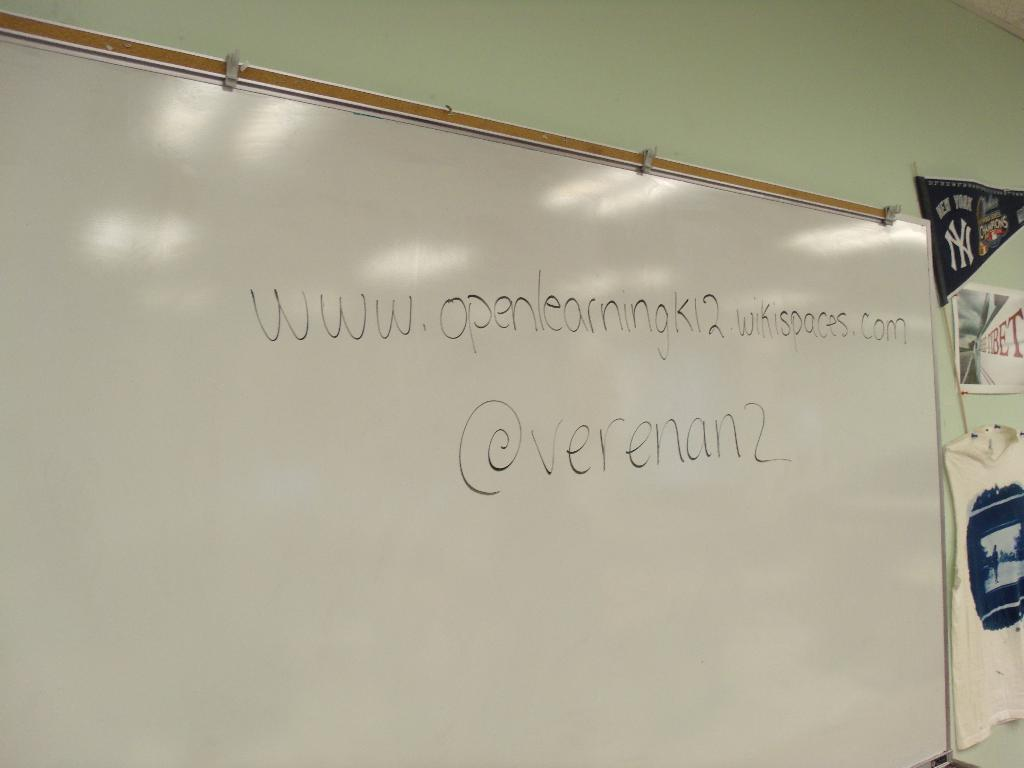<image>
Write a terse but informative summary of the picture. A url is written on a board along with @verenan2. 